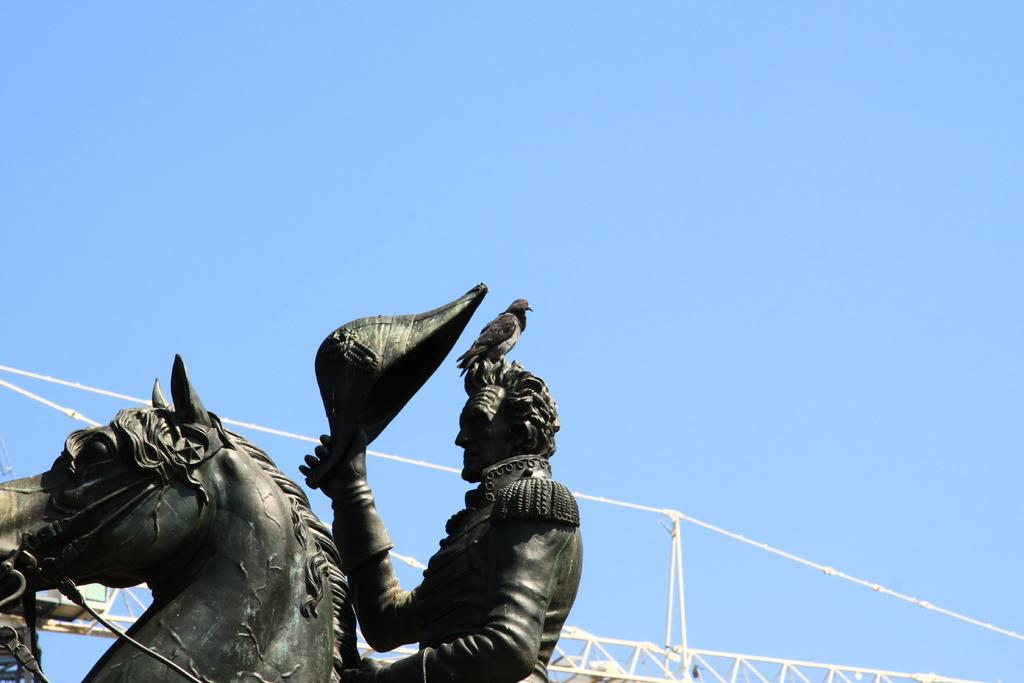What type of animal can be seen in the image? There is a bird in the image. What is the bird standing on? The bird is standing on a statue. What can be seen in the background of the image? There is an iron grill and the sky visible in the background of the image. What type of stone is the bird using to create thunder in the image? There is no stone or thunder present in the image; it features a bird standing on a statue with an iron grill and the sky visible in the background. 